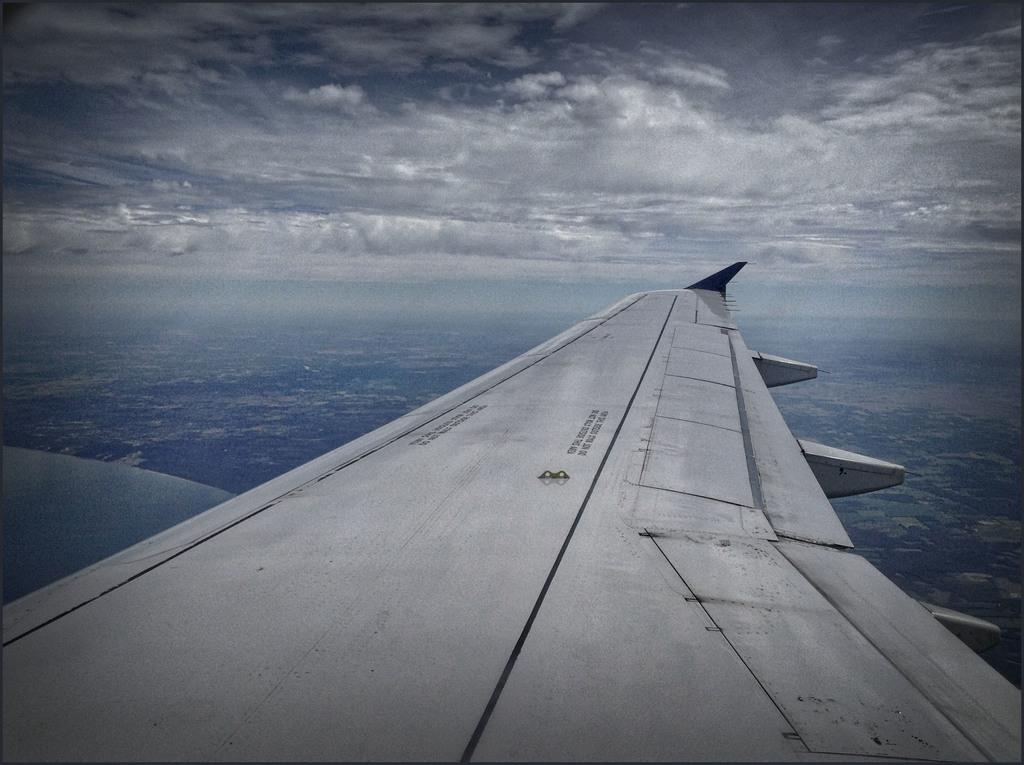In one or two sentences, can you explain what this image depicts? In this image, we can see elevator. Top of the image, we can see a cloudy sky. 